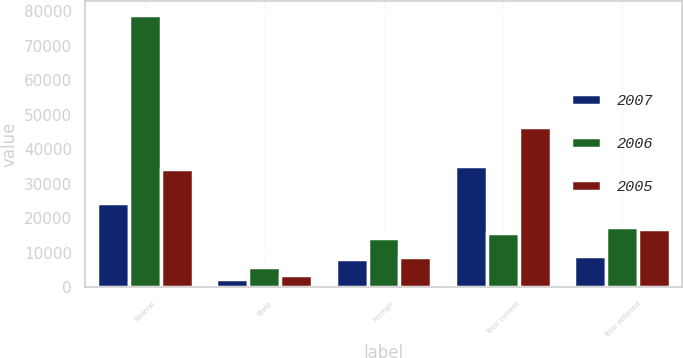<chart> <loc_0><loc_0><loc_500><loc_500><stacked_bar_chart><ecel><fcel>Federal<fcel>State<fcel>Foreign<fcel>Total current<fcel>Total deferred<nl><fcel>2007<fcel>24334<fcel>2437<fcel>8267<fcel>35038<fcel>9023<nl><fcel>2006<fcel>79082<fcel>5837<fcel>14381<fcel>15625<fcel>17516<nl><fcel>2005<fcel>34320<fcel>3436<fcel>8858<fcel>46614<fcel>16869<nl></chart> 